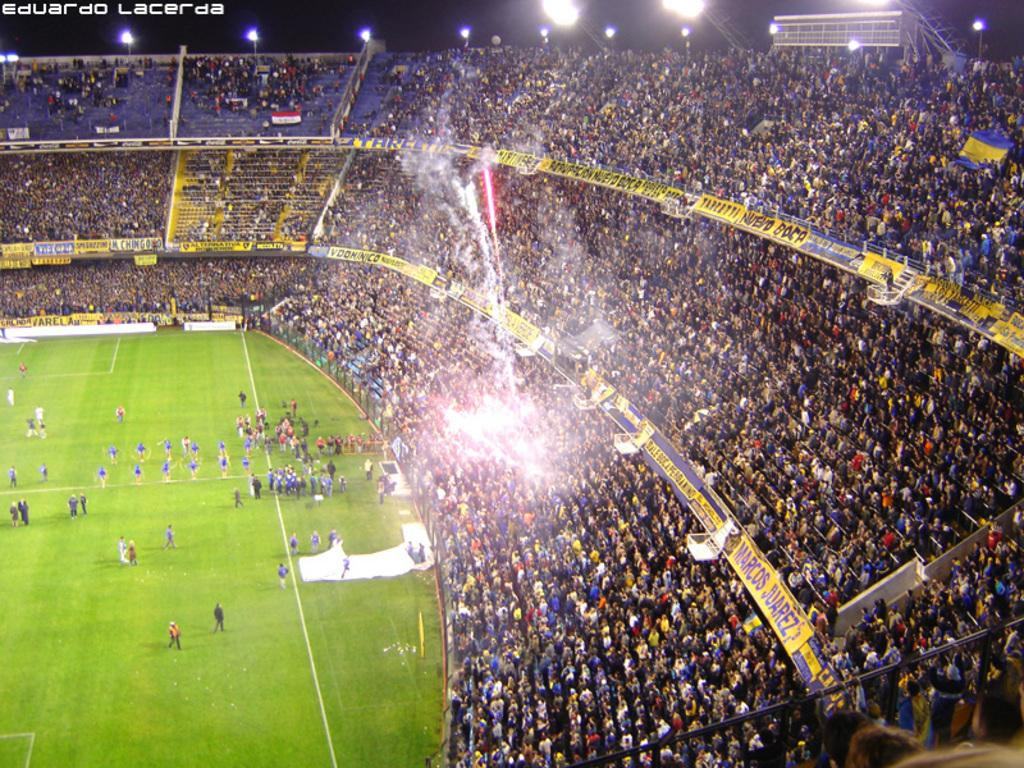Where was the image taken? The image was captured inside a stadium. What can be seen in the image besides the stadium? There is a huge crowd in the image. What is in front of the crowd? There is a ground in front of the crowd. Who else is present in the image besides the crowd? Players are present in the image, and there are other people standing inside the ground. Can you see a hen running across the ground in the image? No, there is no hen present in the image. Are there any bikes visible in the image? No, there are no bikes visible in the image. 